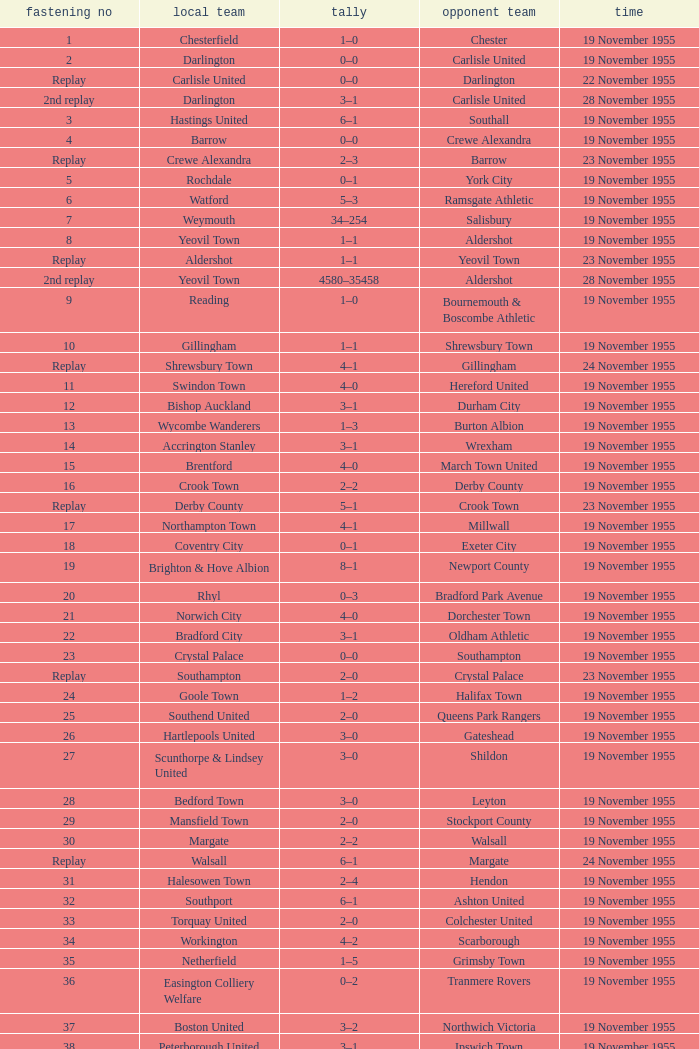What is the home team with scarborough as the away team? Workington. 